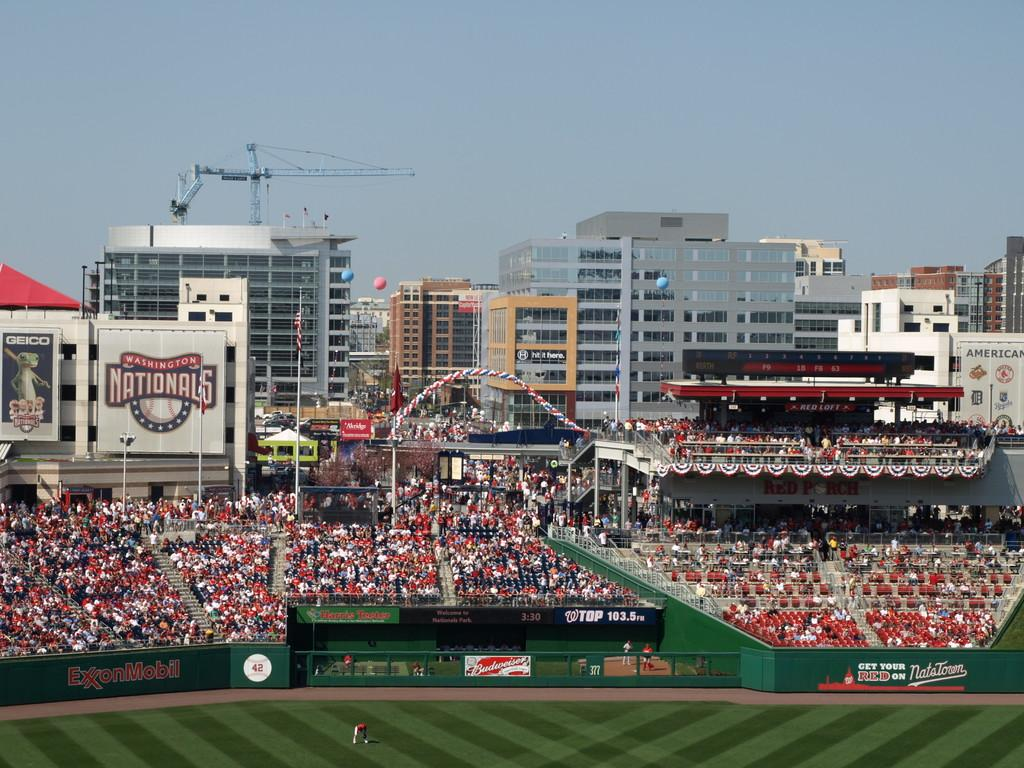<image>
Create a compact narrative representing the image presented. a filled sports stadium for the Washington Nationals 